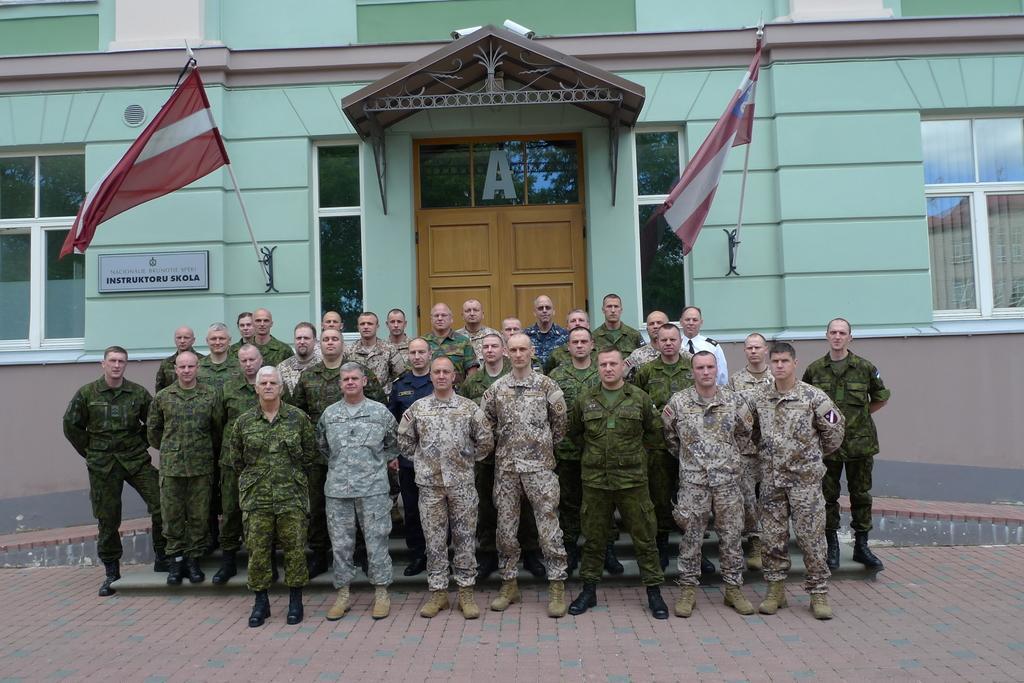Describe this image in one or two sentences. In this image I can see number of people are standing in the front and I can see all of them are wearing uniforms. In the background I can see a building and on the both side of it I can see few flags and windows. I can also see a door in the centre and on the left side of this image I can see a white colour board. I can also see something is written on the board. 